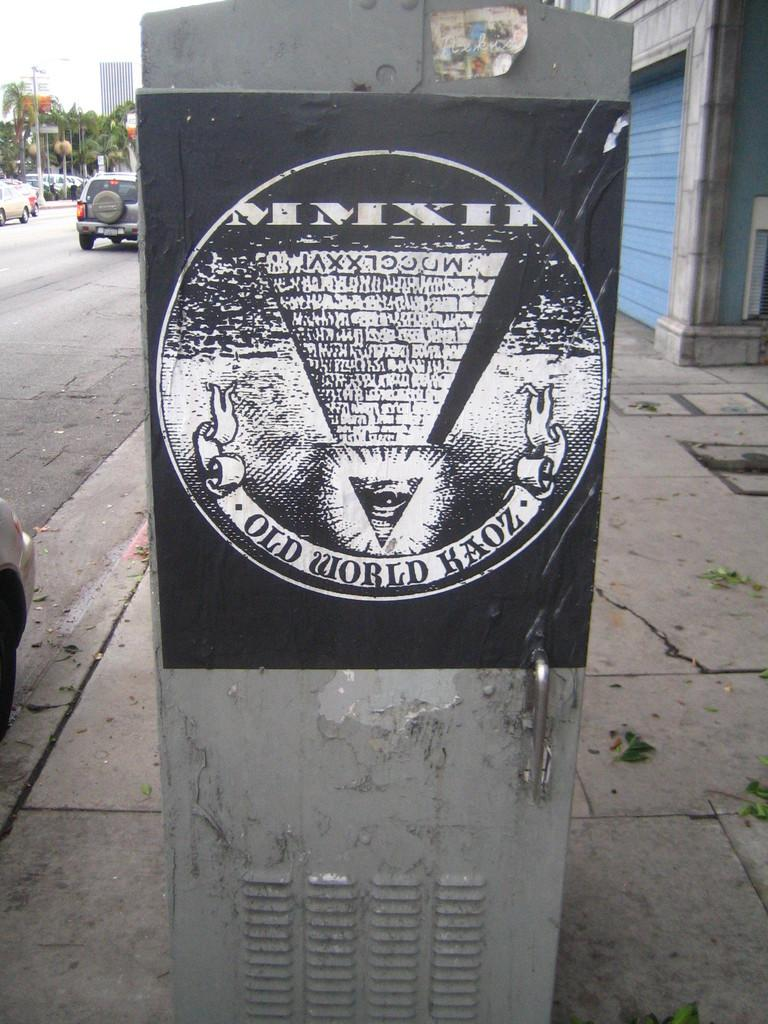<image>
Share a concise interpretation of the image provided. A poster sits on a untility unit which says Old World Haoz. 